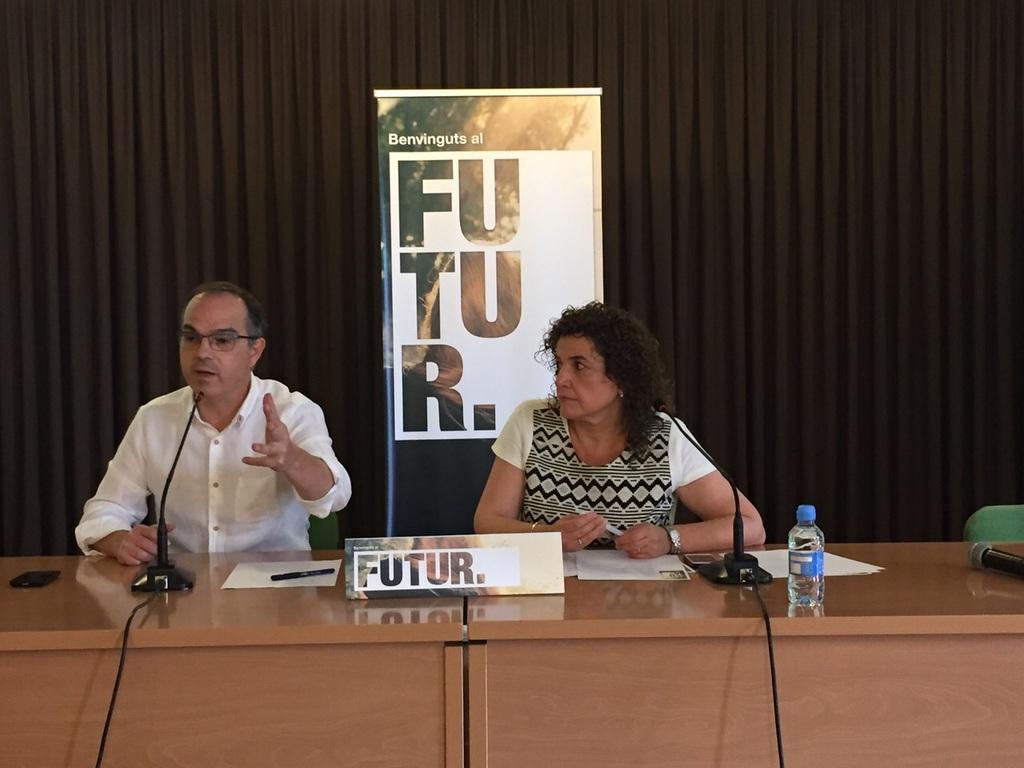Can you describe this image briefly? In this image i can see two persons at the left side of the image there is a person wearing white color shirt in front of him there is a microphone,paper and pen at the right side of the image there is a woman wearing white color dress in front of her there is a microphone ,water bottle and paper at the right side of the image there is a microphone on top of the table and at the background of the image there is a black color sheet. 